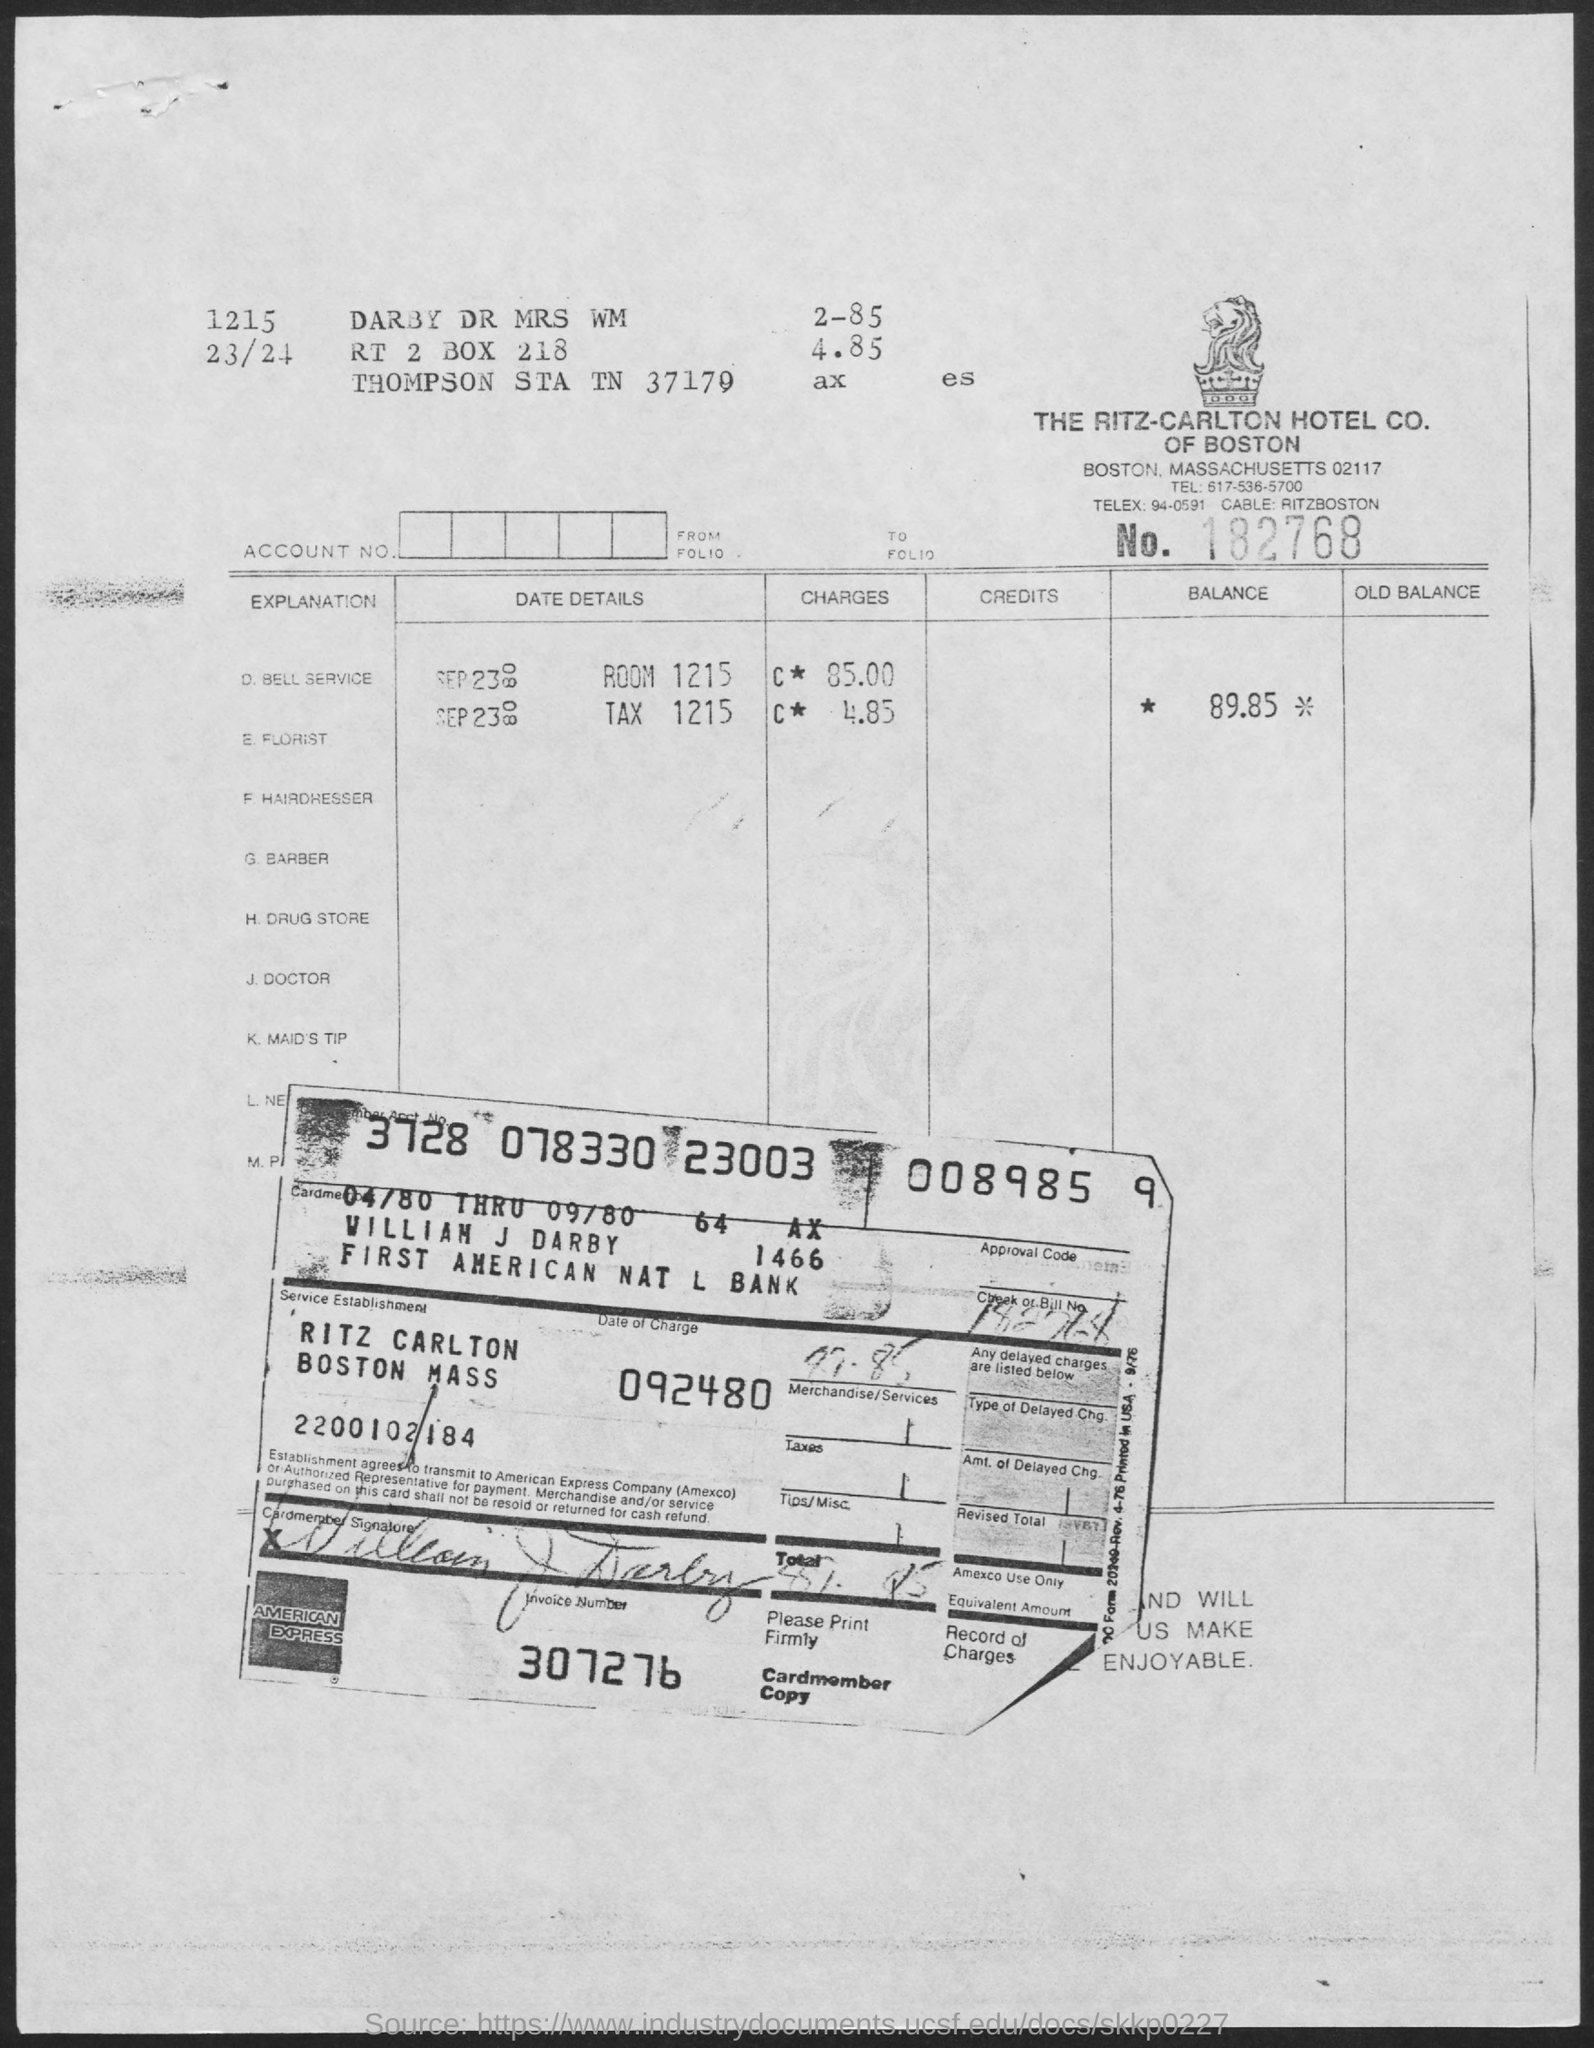Indicate a few pertinent items in this graphic. The room number 1215 has a charge of $85.00. The invoice number is 307276... On what date was the accused charged? The accused's charge was on September 24th, 80. The balance is currently 89.85. William J Darby is the Cardmember. 